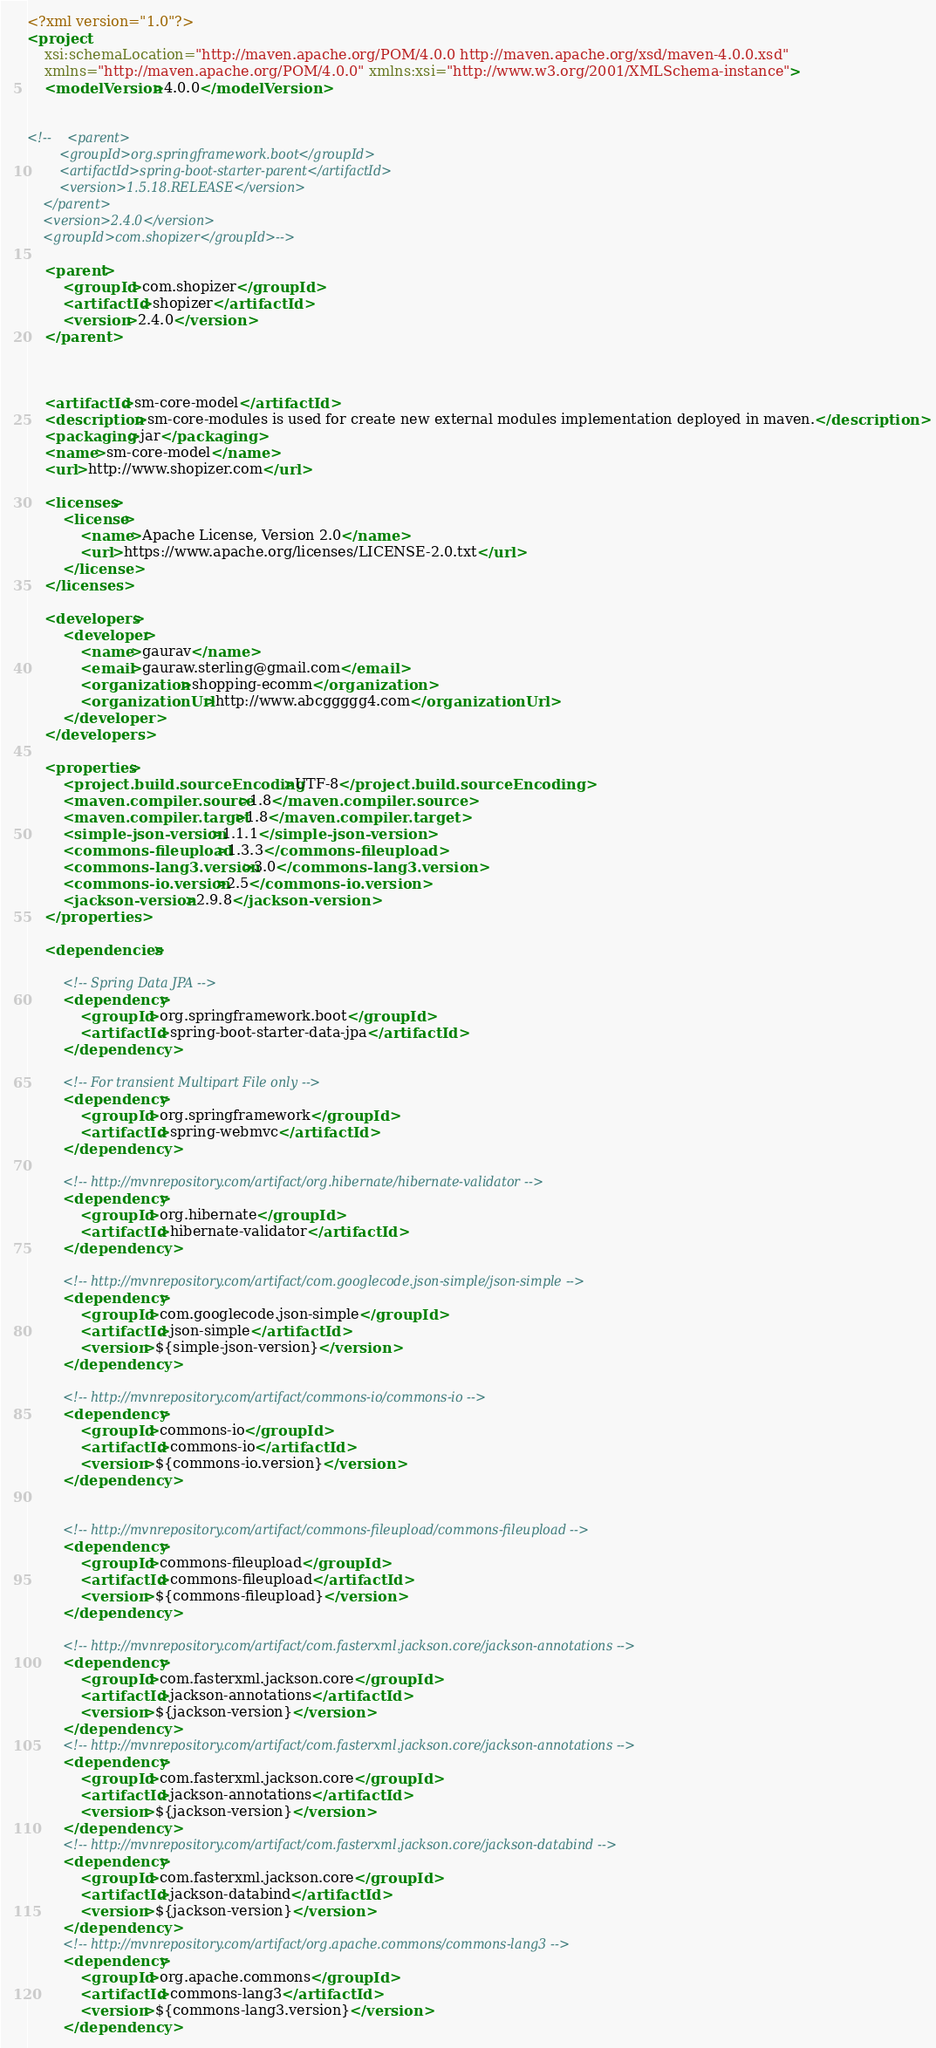Convert code to text. <code><loc_0><loc_0><loc_500><loc_500><_XML_><?xml version="1.0"?>
<project
	xsi:schemaLocation="http://maven.apache.org/POM/4.0.0 http://maven.apache.org/xsd/maven-4.0.0.xsd"
	xmlns="http://maven.apache.org/POM/4.0.0" xmlns:xsi="http://www.w3.org/2001/XMLSchema-instance">
	<modelVersion>4.0.0</modelVersion>
	
	
<!-- 	<parent>
		<groupId>org.springframework.boot</groupId>
		<artifactId>spring-boot-starter-parent</artifactId>
		<version>1.5.18.RELEASE</version>
	</parent>
	<version>2.4.0</version> 
	<groupId>com.shopizer</groupId>-->

	<parent>
		<groupId>com.shopizer</groupId>
		<artifactId>shopizer</artifactId>
		<version>2.4.0</version>
	</parent>



	<artifactId>sm-core-model</artifactId>
	<description>sm-core-modules is used for create new external modules implementation deployed in maven.</description>
	<packaging>jar</packaging>
	<name>sm-core-model</name>
	<url>http://www.shopizer.com</url>

	<licenses>
		<license>
			<name>Apache License, Version 2.0</name>
			<url>https://www.apache.org/licenses/LICENSE-2.0.txt</url>
		</license>
	</licenses>

	<developers>
		<developer>
			<name>gaurav</name>
			<email>gauraw.sterling@gmail.com</email>
			<organization>shopping-ecomm</organization>
			<organizationUrl>http://www.abcggggg4.com</organizationUrl>
		</developer>
	</developers>

	<properties>
		<project.build.sourceEncoding>UTF-8</project.build.sourceEncoding>
		<maven.compiler.source>1.8</maven.compiler.source>
		<maven.compiler.target>1.8</maven.compiler.target>
		<simple-json-version>1.1.1</simple-json-version>
		<commons-fileupload>1.3.3</commons-fileupload>
		<commons-lang3.version>3.0</commons-lang3.version>
		<commons-io.version>2.5</commons-io.version>
		<jackson-version>2.9.8</jackson-version>
	</properties>

	<dependencies>

		<!-- Spring Data JPA -->
		<dependency>
			<groupId>org.springframework.boot</groupId>
			<artifactId>spring-boot-starter-data-jpa</artifactId>
		</dependency>

		<!-- For transient Multipart File only -->
		<dependency>
			<groupId>org.springframework</groupId>
			<artifactId>spring-webmvc</artifactId>
		</dependency>

		<!-- http://mvnrepository.com/artifact/org.hibernate/hibernate-validator -->
		<dependency>
			<groupId>org.hibernate</groupId>
			<artifactId>hibernate-validator</artifactId>
		</dependency>

		<!-- http://mvnrepository.com/artifact/com.googlecode.json-simple/json-simple -->
		<dependency>
			<groupId>com.googlecode.json-simple</groupId>
			<artifactId>json-simple</artifactId>
			<version>${simple-json-version}</version>
		</dependency>

		<!-- http://mvnrepository.com/artifact/commons-io/commons-io -->
		<dependency>
			<groupId>commons-io</groupId>
			<artifactId>commons-io</artifactId>
			<version>${commons-io.version}</version>
		</dependency>


		<!-- http://mvnrepository.com/artifact/commons-fileupload/commons-fileupload -->
		<dependency>
			<groupId>commons-fileupload</groupId>
			<artifactId>commons-fileupload</artifactId>
			<version>${commons-fileupload}</version>
		</dependency>

		<!-- http://mvnrepository.com/artifact/com.fasterxml.jackson.core/jackson-annotations -->
		<dependency>
			<groupId>com.fasterxml.jackson.core</groupId>
			<artifactId>jackson-annotations</artifactId>
			<version>${jackson-version}</version>
		</dependency>
		<!-- http://mvnrepository.com/artifact/com.fasterxml.jackson.core/jackson-annotations -->
		<dependency>
			<groupId>com.fasterxml.jackson.core</groupId>
			<artifactId>jackson-annotations</artifactId>
			<version>${jackson-version}</version>
		</dependency>
		<!-- http://mvnrepository.com/artifact/com.fasterxml.jackson.core/jackson-databind -->
		<dependency>
			<groupId>com.fasterxml.jackson.core</groupId>
			<artifactId>jackson-databind</artifactId>
			<version>${jackson-version}</version>
		</dependency>
		<!-- http://mvnrepository.com/artifact/org.apache.commons/commons-lang3 -->
		<dependency>
			<groupId>org.apache.commons</groupId>
			<artifactId>commons-lang3</artifactId>
			<version>${commons-lang3.version}</version>
		</dependency>
</code> 